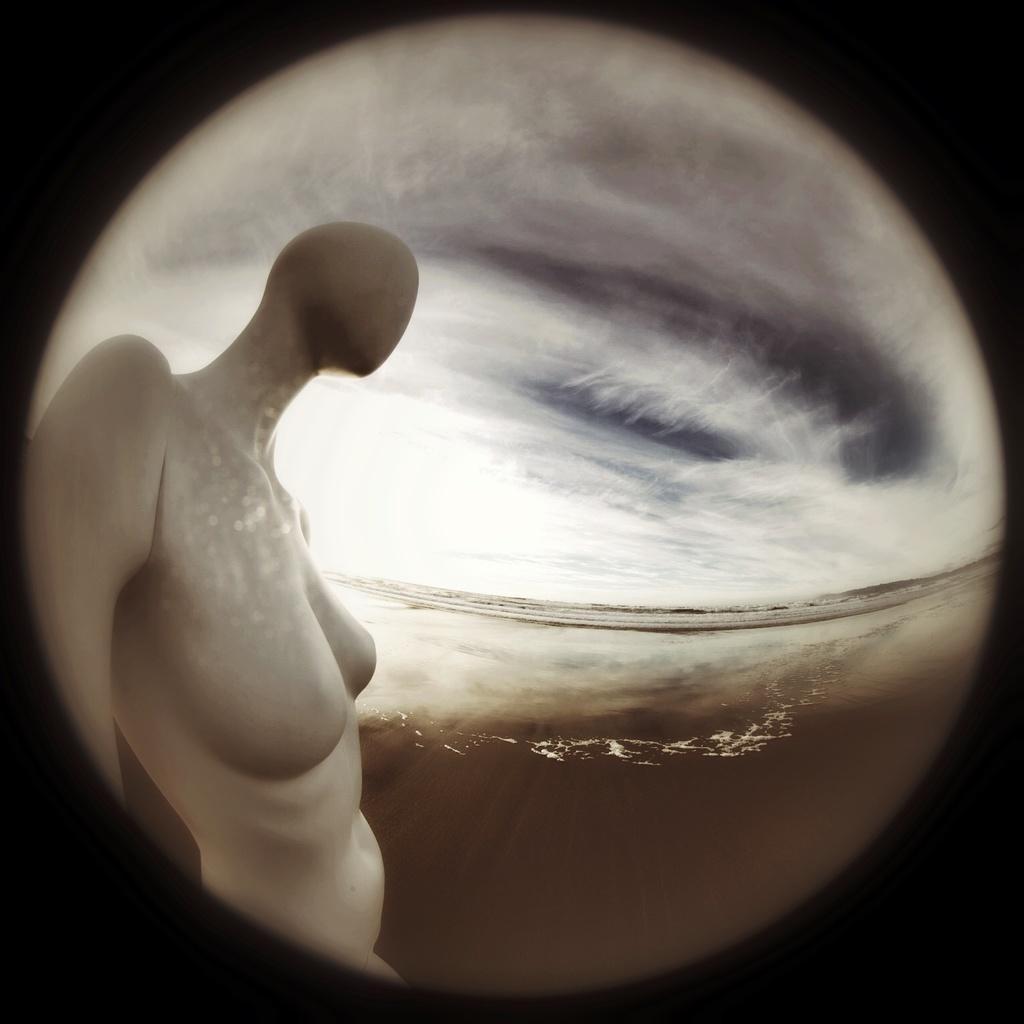Please provide a concise description of this image. There is a circular image, in which there is a person's statue. In the background, there are clouds in the sky. Around this circular image, there is a dark color border. 